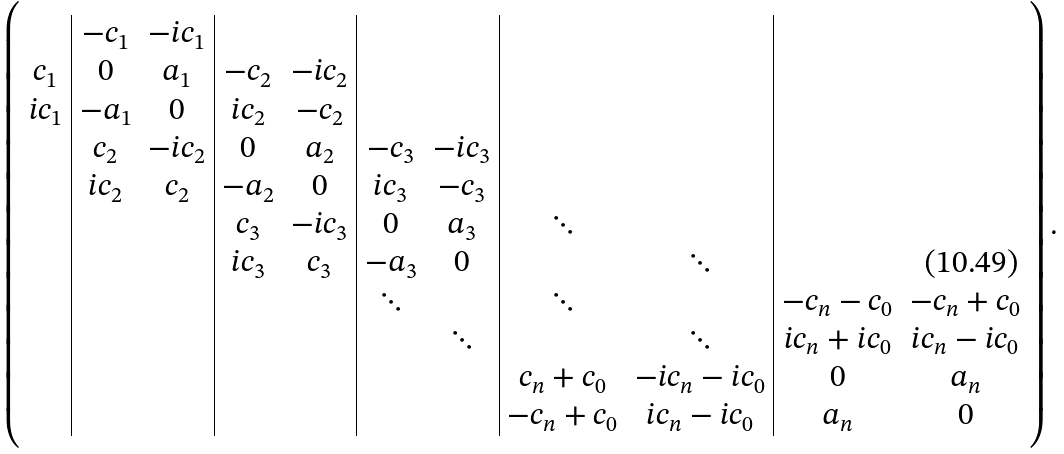Convert formula to latex. <formula><loc_0><loc_0><loc_500><loc_500>\left ( \begin{array} { c | c c | c c | c c | c c | c c } & - c _ { 1 } & - i c _ { 1 } & \ & \ & \ & \ & \ & \ \\ c _ { 1 } & 0 & a _ { 1 } & - c _ { 2 } & - i c _ { 2 } & & & & \\ i c _ { 1 } & - a _ { 1 } & 0 & i c _ { 2 } & - c _ { 2 } & & & & \\ & c _ { 2 } & - i c _ { 2 } & 0 & a _ { 2 } & - c _ { 3 } & - i c _ { 3 } & & & & \\ & i c _ { 2 } & c _ { 2 } & - a _ { 2 } & 0 & i c _ { 3 } & - c _ { 3 } & & & & \\ & & & c _ { 3 } & - i c _ { 3 } & 0 & a _ { 3 } & \ddots & & \\ & & & i c _ { 3 } & c _ { 3 } & - a _ { 3 } & 0 & & \ddots & \\ & & & & & \ddots & & \ddots & & - c _ { n } - c _ { 0 } & - c _ { n } + c _ { 0 } \\ & & & & & & \ddots & & \ddots & i c _ { n } + i c _ { 0 } & i c _ { n } - i c _ { 0 } \\ & & & & & & & c _ { n } + c _ { 0 } & - i c _ { n } - i c _ { 0 } & 0 & a _ { n } \\ & & & & & & & - c _ { n } + c _ { 0 } & i c _ { n } - i c _ { 0 } & a _ { n } & 0 \end{array} \right ) .</formula> 